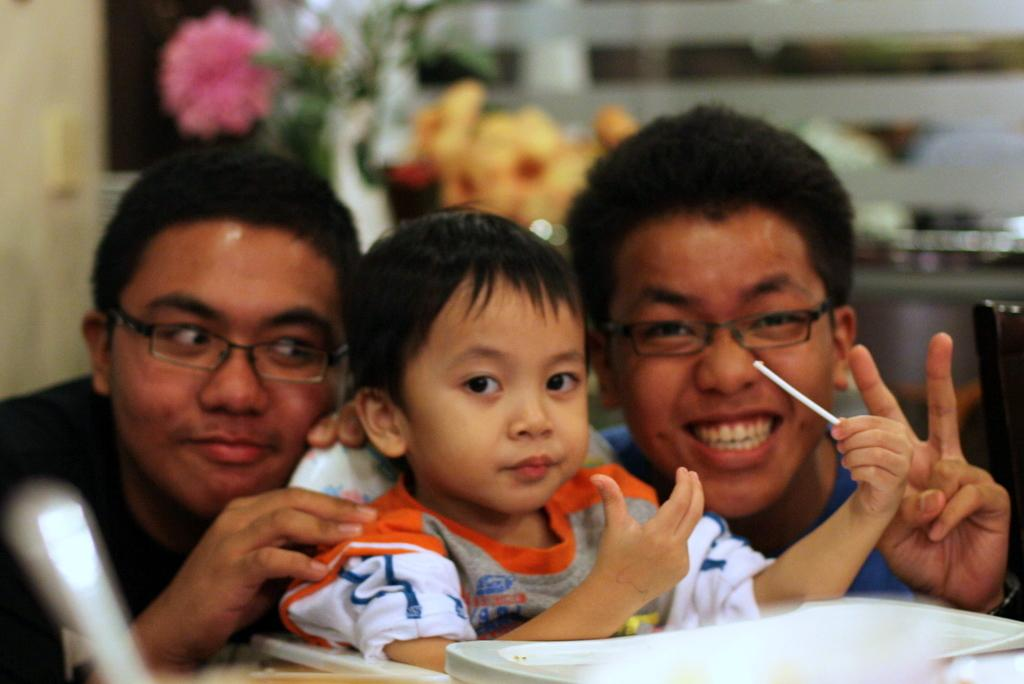What is the main subject of the image? The main subject of the image is a kid. Can you describe the kid's position in the image? The kid is between two persons in the image. What type of motion can be seen in the image? There is no motion visible in the image; the image is a still photograph. What kind of mine is depicted in the image? There is no mine present in the image. 